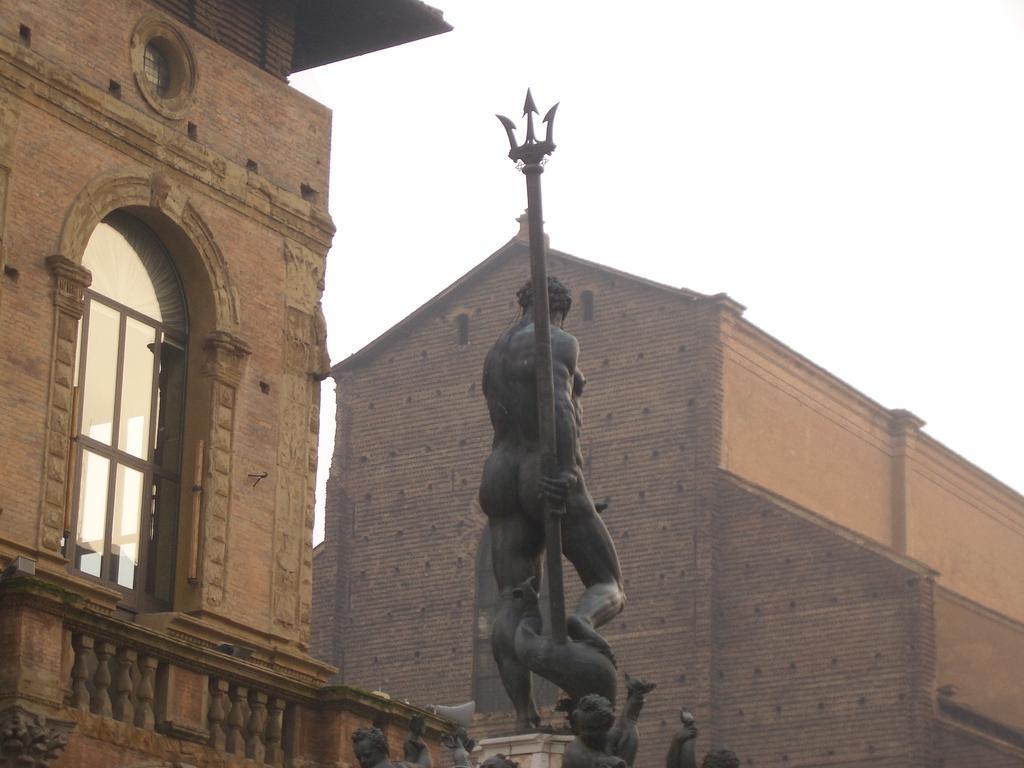Can you describe this image briefly? In the center of the image there is a statue. In the background of the image there are buildings. There is a window. At the top of the image there is sky. 